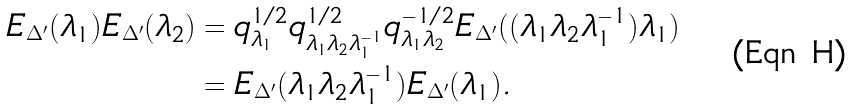<formula> <loc_0><loc_0><loc_500><loc_500>E _ { \Delta ^ { \prime } } ( \lambda _ { 1 } ) E _ { \Delta ^ { \prime } } ( \lambda _ { 2 } ) & = q _ { \lambda _ { 1 } } ^ { 1 / 2 } q _ { \lambda _ { 1 } \lambda _ { 2 } \lambda _ { 1 } ^ { - 1 } } ^ { 1 / 2 } q _ { \lambda _ { 1 } \lambda _ { 2 } } ^ { - 1 / 2 } E _ { \Delta ^ { \prime } } ( ( \lambda _ { 1 } \lambda _ { 2 } \lambda _ { 1 } ^ { - 1 } ) \lambda _ { 1 } ) \\ & = E _ { \Delta ^ { \prime } } ( \lambda _ { 1 } \lambda _ { 2 } \lambda _ { 1 } ^ { - 1 } ) E _ { \Delta ^ { \prime } } ( \lambda _ { 1 } ) .</formula> 